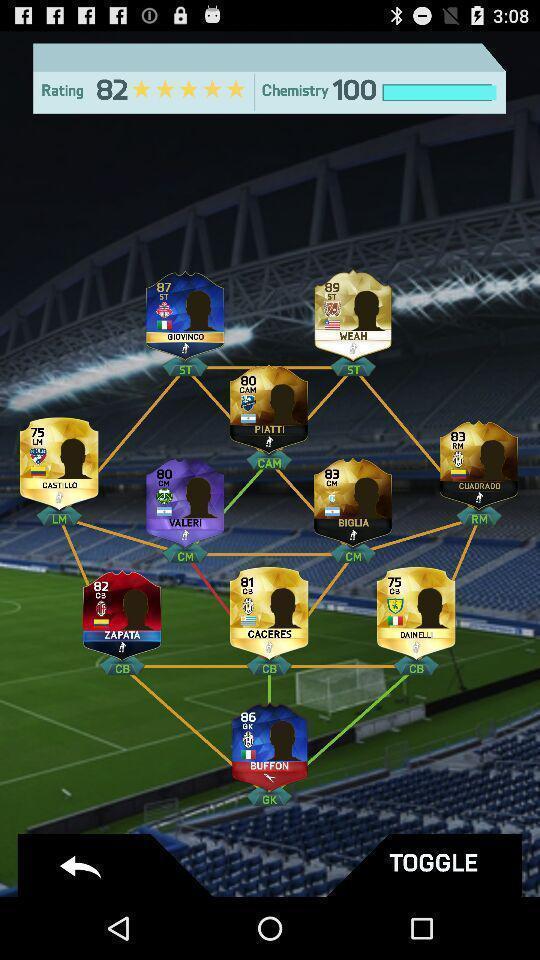Describe the content in this image. Social app for playing games. 